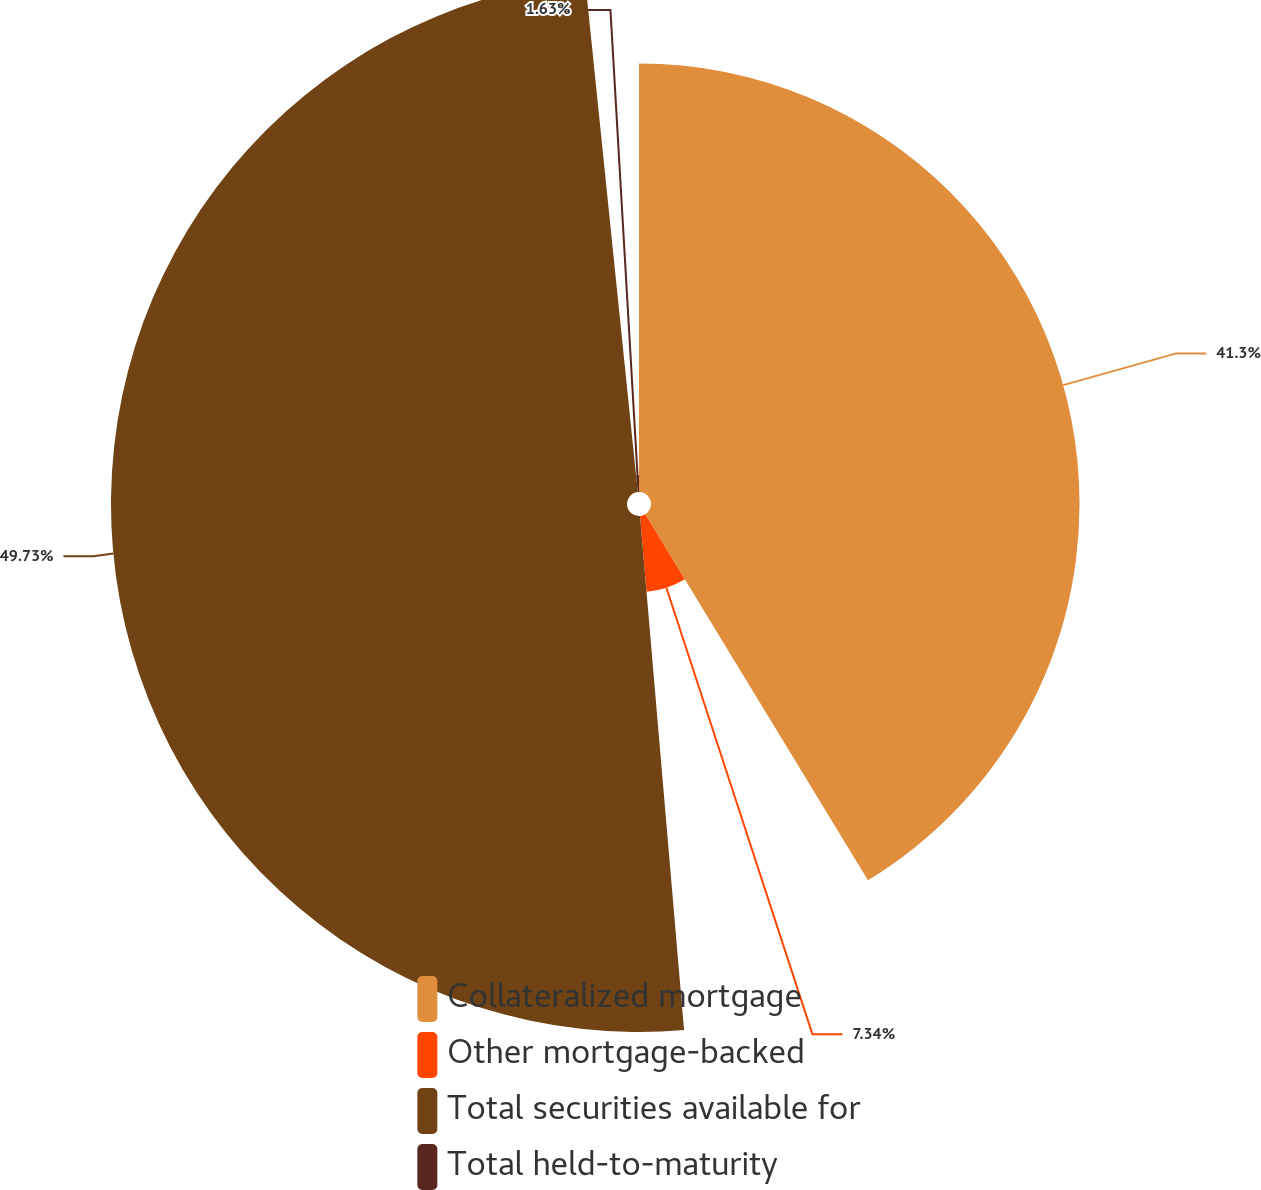Convert chart. <chart><loc_0><loc_0><loc_500><loc_500><pie_chart><fcel>Collateralized mortgage<fcel>Other mortgage-backed<fcel>Total securities available for<fcel>Total held-to-maturity<nl><fcel>41.3%<fcel>7.34%<fcel>49.73%<fcel>1.63%<nl></chart> 